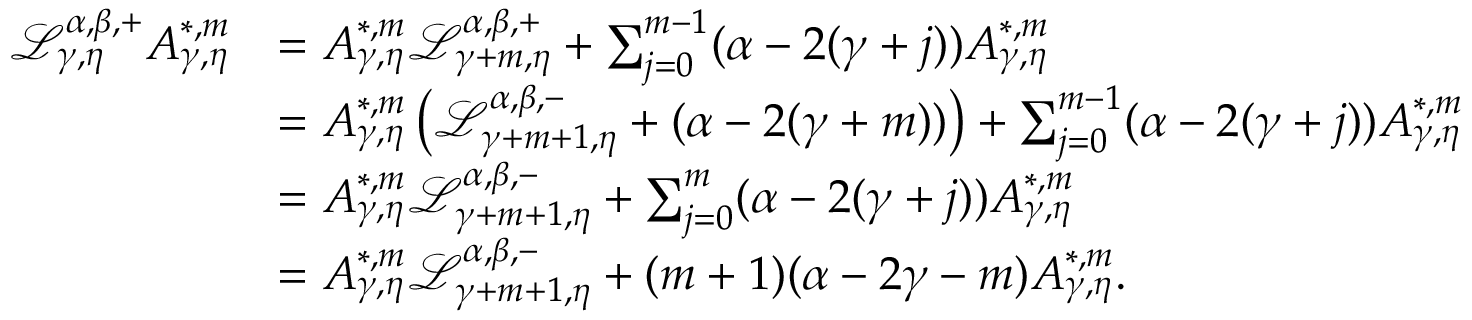Convert formula to latex. <formula><loc_0><loc_0><loc_500><loc_500>\begin{array} { r l } { \mathcal { L } _ { \gamma , \eta } ^ { \alpha , \beta , + } A _ { \gamma , \eta } ^ { * , m } } & { = A _ { \gamma , \eta } ^ { * , m } \mathcal { L } _ { \gamma + m , \eta } ^ { \alpha , \beta , + } + \sum _ { j = 0 } ^ { m - 1 } ( \alpha - 2 ( \gamma + j ) ) A _ { \gamma , \eta } ^ { * , m } } \\ & { = A _ { \gamma , \eta } ^ { * , m } \left ( \mathcal { L } _ { \gamma + m + 1 , \eta } ^ { \alpha , \beta , - } + ( \alpha - 2 ( \gamma + m ) ) \right ) + \sum _ { j = 0 } ^ { m - 1 } ( \alpha - 2 ( \gamma + j ) ) A _ { \gamma , \eta } ^ { * , m } } \\ & { = A _ { \gamma , \eta } ^ { * , m } \mathcal { L } _ { \gamma + m + 1 , \eta } ^ { \alpha , \beta , - } + \sum _ { j = 0 } ^ { m } ( \alpha - 2 ( \gamma + j ) ) A _ { \gamma , \eta } ^ { * , m } } \\ & { = A _ { \gamma , \eta } ^ { * , m } \mathcal { L } _ { \gamma + m + 1 , \eta } ^ { \alpha , \beta , - } + ( m + 1 ) ( \alpha - 2 \gamma - m ) A _ { \gamma , \eta } ^ { * , m } . } \end{array}</formula> 